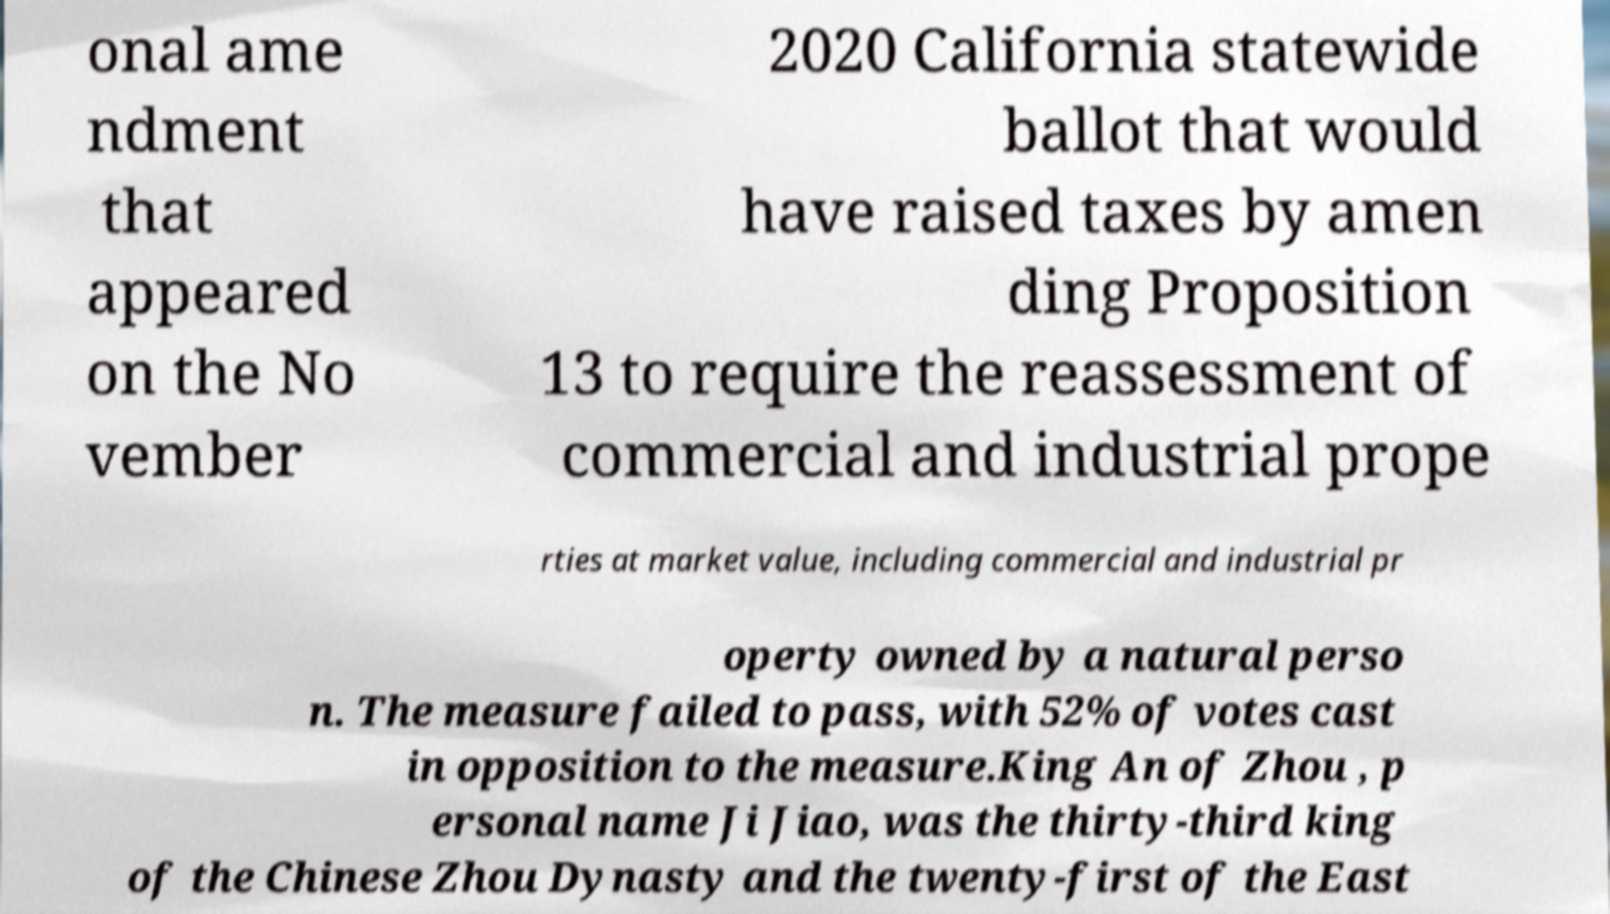There's text embedded in this image that I need extracted. Can you transcribe it verbatim? onal ame ndment that appeared on the No vember 2020 California statewide ballot that would have raised taxes by amen ding Proposition 13 to require the reassessment of commercial and industrial prope rties at market value, including commercial and industrial pr operty owned by a natural perso n. The measure failed to pass, with 52% of votes cast in opposition to the measure.King An of Zhou , p ersonal name Ji Jiao, was the thirty-third king of the Chinese Zhou Dynasty and the twenty-first of the East 